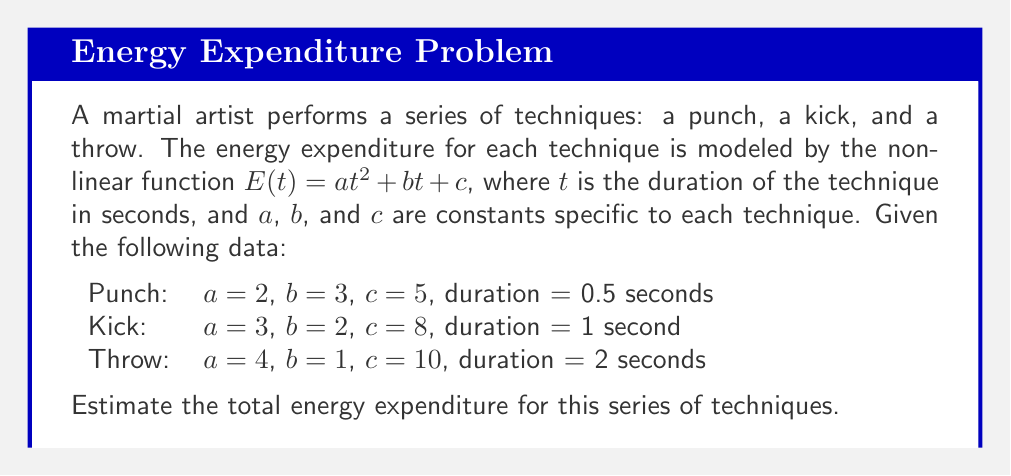What is the answer to this math problem? To solve this problem, we need to calculate the energy expenditure for each technique using the given nonlinear function and then sum the results. Let's break it down step by step:

1. Energy expenditure for the punch:
   $E_{punch}(t) = 2t^2 + 3t + 5$
   $E_{punch}(0.5) = 2(0.5)^2 + 3(0.5) + 5$
   $E_{punch}(0.5) = 2(0.25) + 1.5 + 5 = 0.5 + 1.5 + 5 = 7$ units

2. Energy expenditure for the kick:
   $E_{kick}(t) = 3t^2 + 2t + 8$
   $E_{kick}(1) = 3(1)^2 + 2(1) + 8$
   $E_{kick}(1) = 3 + 2 + 8 = 13$ units

3. Energy expenditure for the throw:
   $E_{throw}(t) = 4t^2 + t + 10$
   $E_{throw}(2) = 4(2)^2 + 2 + 10$
   $E_{throw}(2) = 4(4) + 2 + 10 = 16 + 2 + 10 = 28$ units

4. Total energy expenditure:
   $E_{total} = E_{punch} + E_{kick} + E_{throw}$
   $E_{total} = 7 + 13 + 28 = 48$ units

Therefore, the total energy expenditure for this series of techniques is 48 units.
Answer: 48 units 